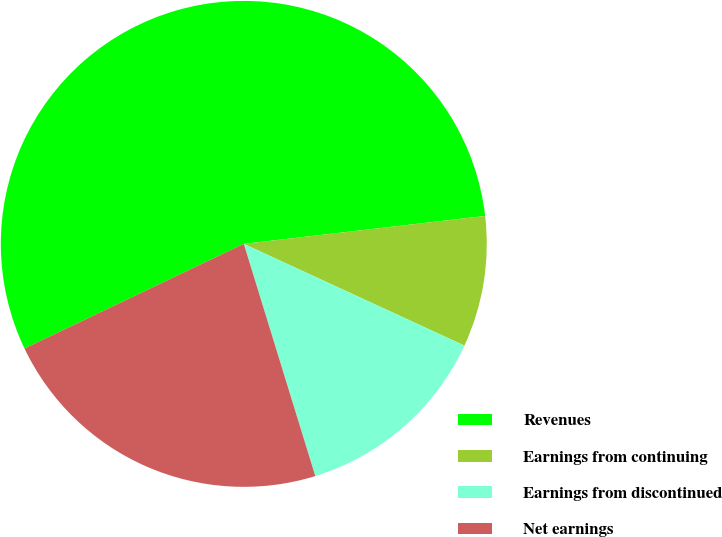Convert chart to OTSL. <chart><loc_0><loc_0><loc_500><loc_500><pie_chart><fcel>Revenues<fcel>Earnings from continuing<fcel>Earnings from discontinued<fcel>Net earnings<nl><fcel>55.25%<fcel>8.71%<fcel>13.37%<fcel>22.67%<nl></chart> 